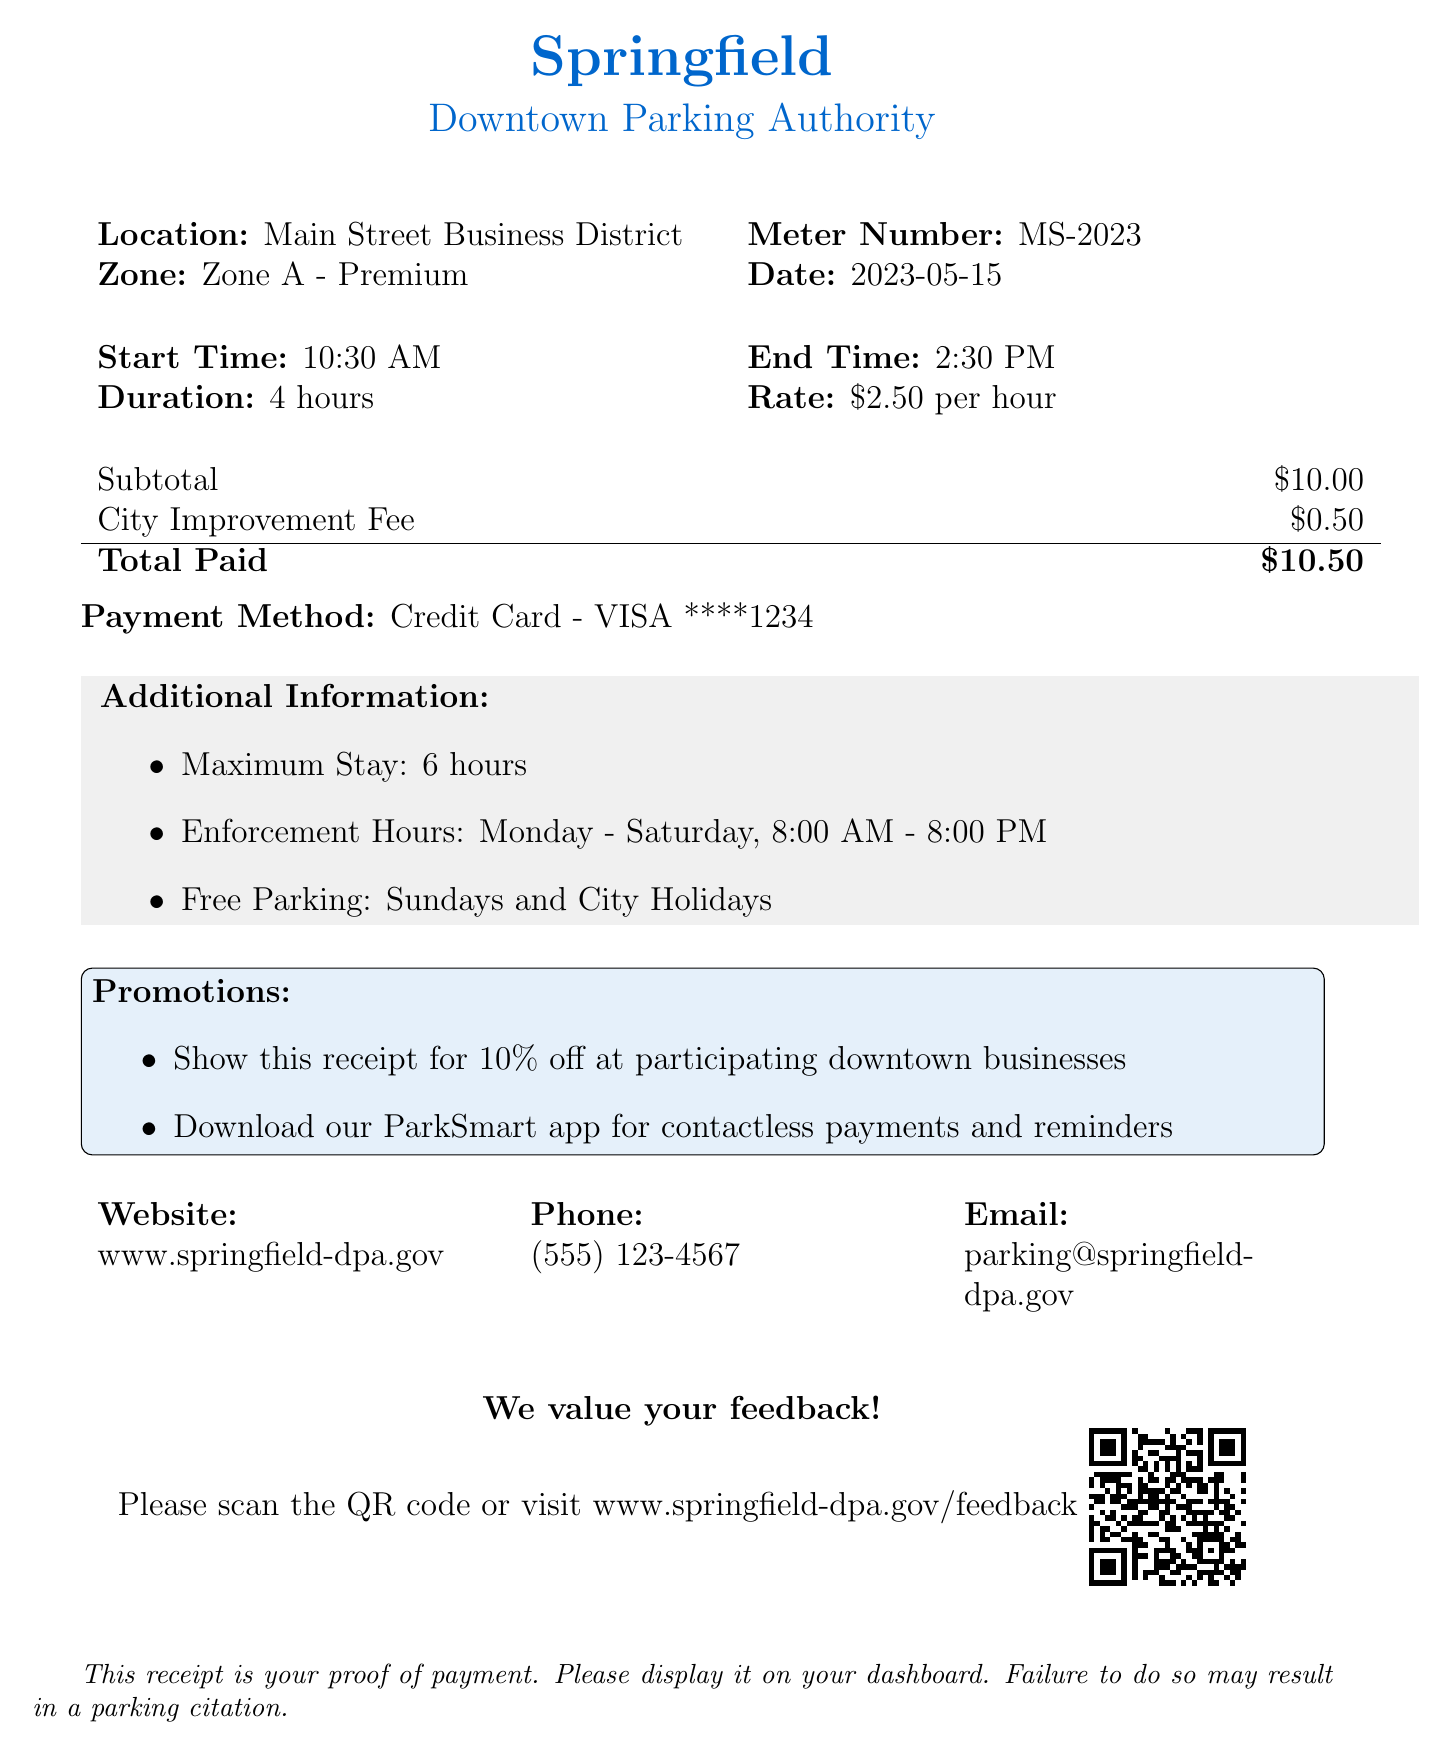What is the date of the transaction? The transaction date is specified in the document under transaction_info as 2023-05-15.
Answer: 2023-05-15 What is the total amount paid? The total amount paid is found in the payment_details section as the total paid amount of $10.50.
Answer: $10.50 What is the parking zone designation? The parking zone designation is noted under parking_details as Zone A - Premium.
Answer: Zone A - Premium How long was the parking duration? The duration of parking is mentioned in the transaction_info as 4 hours.
Answer: 4 hours What is the maximum stay allowed? The maximum stay allowed is provided under additional_info as 6 hours.
Answer: 6 hours What payment method was used? The payment method used is indicated in the payment_details section as Credit Card - VISA ****1234.
Answer: Credit Card - VISA ****1234 What is the city improvement fee? The city improvement fee can be found in the payment_details as $0.50.
Answer: $0.50 What is the enforcement times for parking? The enforcement times are specified in the additional_info as Monday - Saturday, 8:00 AM - 8:00 PM.
Answer: Monday - Saturday, 8:00 AM - 8:00 PM What promotion is available with this receipt? The available promotion is provided under promotions, stating to show the receipt for 10% off at participating downtown businesses.
Answer: 10% off at participating downtown businesses 